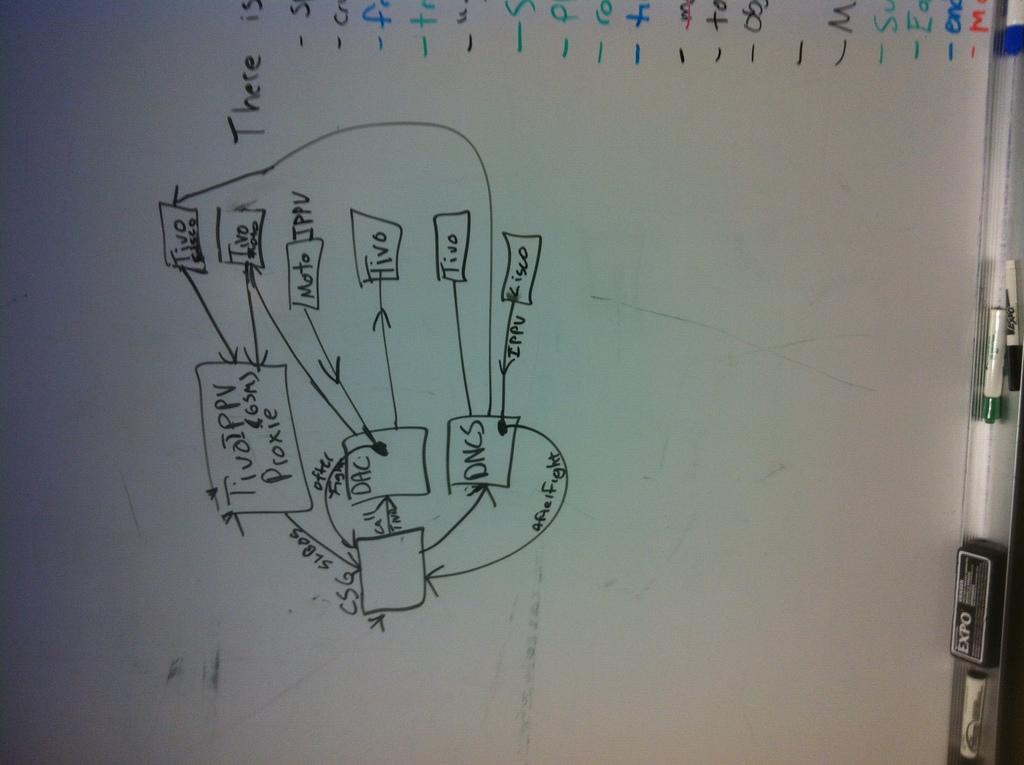What word is to the right of the line?
Keep it short and to the point. There. 